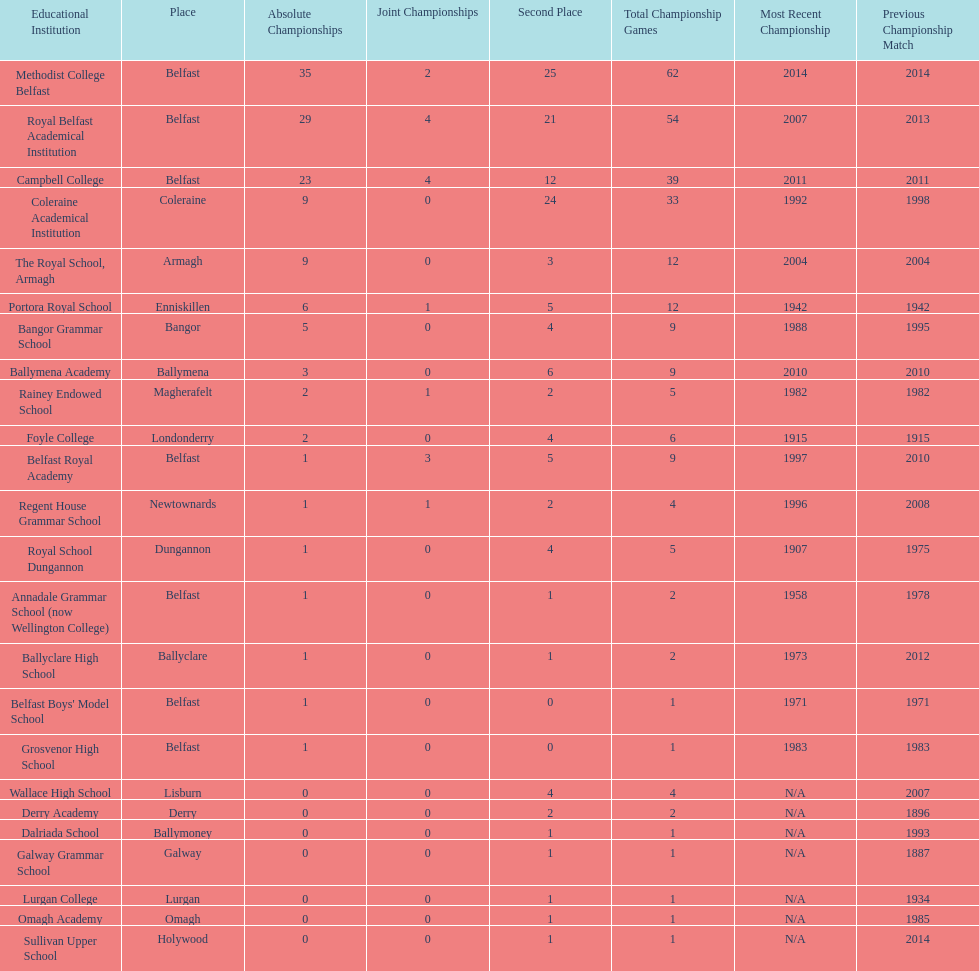How many schools have at least 5 outright titles? 7. 